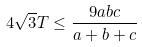<formula> <loc_0><loc_0><loc_500><loc_500>4 \sqrt { 3 } T \leq \frac { 9 a b c } { a + b + c }</formula> 